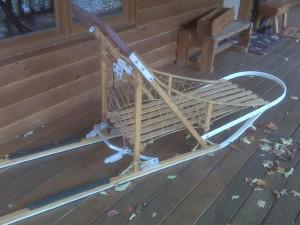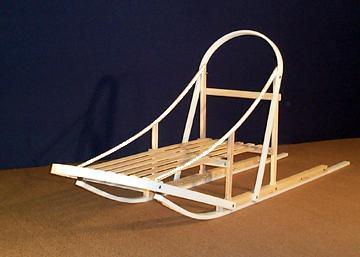The first image is the image on the left, the second image is the image on the right. Considering the images on both sides, is "In the image on the left there is one dog." valid? Answer yes or no. No. The first image is the image on the left, the second image is the image on the right. Analyze the images presented: Is the assertion "The left image shows a dog in front of a riderless sled featuring red on it, and the right image shows a row of empty sleds." valid? Answer yes or no. No. 